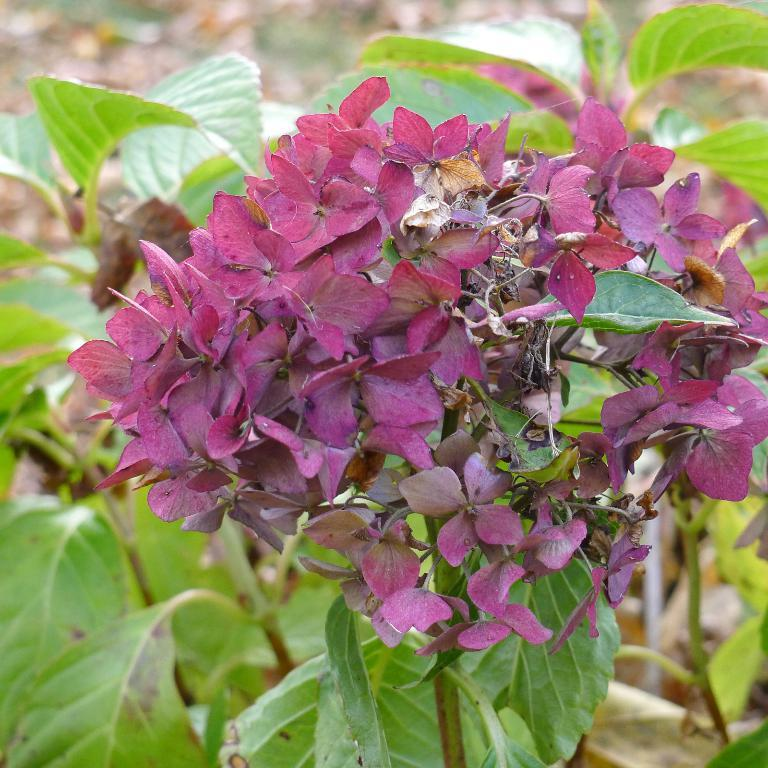What type of living organisms can be seen in the image? There are flowers and plants in the image. Can you describe the plants in the image? The plants in the image are not specified, but they are present alongside the flowers. How many branches can be seen in the image? There is no mention of branches in the image; it only features flowers and plants. What causes the flock to move in the image? There is no flock present in the image; it only features flowers and plants. 